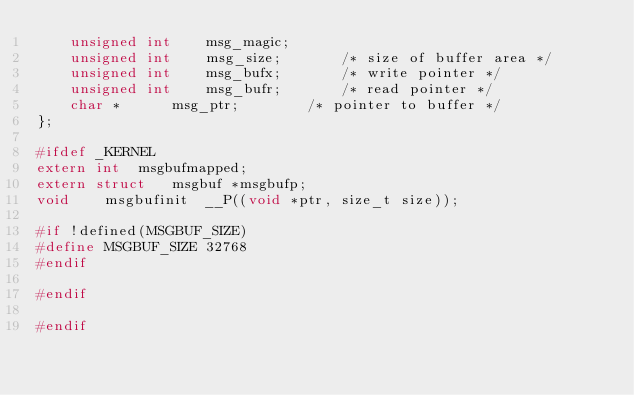Convert code to text. <code><loc_0><loc_0><loc_500><loc_500><_C_>	unsigned int	msg_magic;
	unsigned int	msg_size;		/* size of buffer area */
	unsigned int	msg_bufx;		/* write pointer */
	unsigned int	msg_bufr;		/* read pointer */
	char * 		msg_ptr;		/* pointer to buffer */
};

#ifdef _KERNEL
extern int	msgbufmapped;
extern struct	msgbuf *msgbufp;
void	msgbufinit	__P((void *ptr, size_t size));

#if !defined(MSGBUF_SIZE)
#define	MSGBUF_SIZE	32768
#endif

#endif

#endif
</code> 